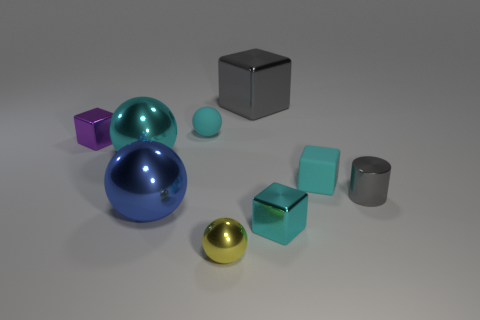Subtract 1 cylinders. How many cylinders are left? 0 Subtract all purple cubes. How many cubes are left? 3 Subtract all large cyan spheres. How many spheres are left? 3 Subtract all cyan cubes. How many yellow balls are left? 1 Subtract all red shiny objects. Subtract all small cyan cubes. How many objects are left? 7 Add 7 small gray cylinders. How many small gray cylinders are left? 8 Add 2 cyan cubes. How many cyan cubes exist? 4 Subtract 0 red cylinders. How many objects are left? 9 Subtract all balls. How many objects are left? 5 Subtract all gray blocks. Subtract all purple cylinders. How many blocks are left? 3 